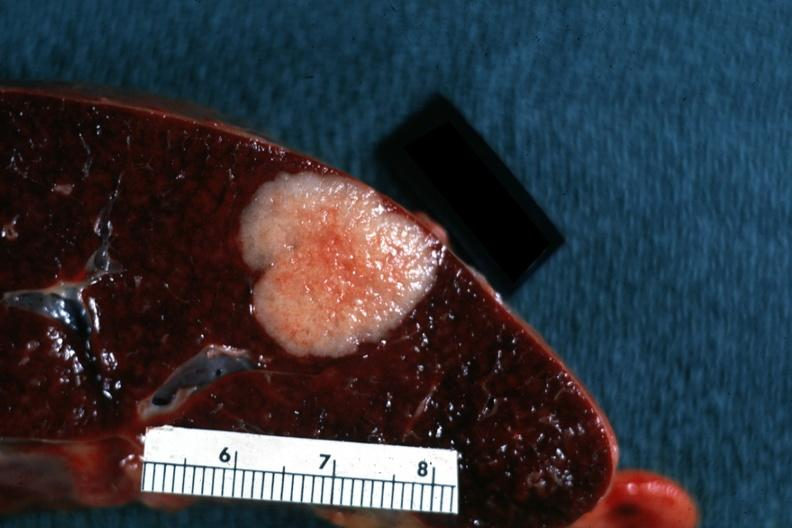does anencephaly show very nice close-up shot of typical metastatic lesion primary tumor in colon?
Answer the question using a single word or phrase. No 